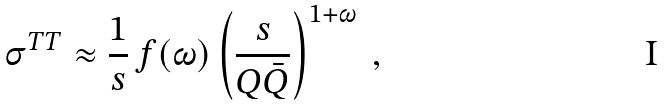<formula> <loc_0><loc_0><loc_500><loc_500>\sigma ^ { T T } \approx \frac { 1 } { s } \, f ( \omega ) \left ( \frac { s } { Q \bar { Q } } \right ) ^ { 1 + \omega } \ ,</formula> 